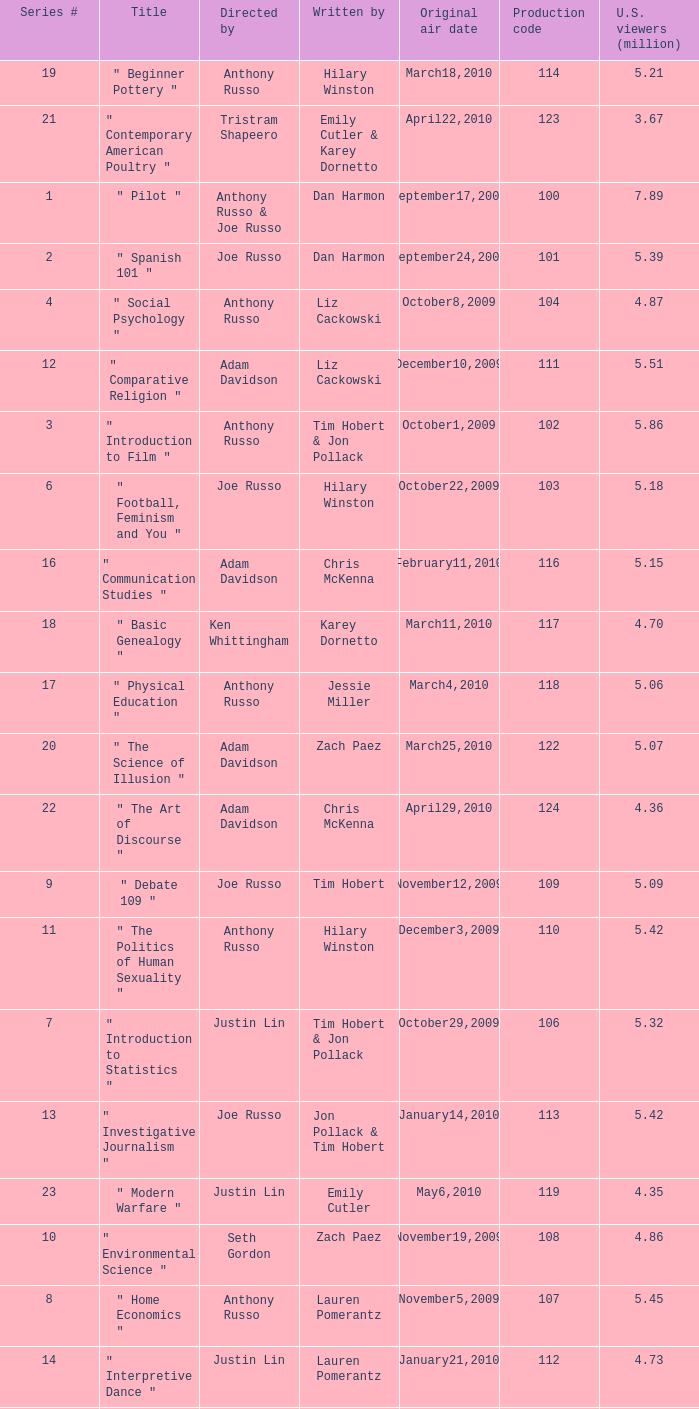Would you be able to parse every entry in this table? {'header': ['Series #', 'Title', 'Directed by', 'Written by', 'Original air date', 'Production code', 'U.S. viewers (million)'], 'rows': [['19', '" Beginner Pottery "', 'Anthony Russo', 'Hilary Winston', 'March18,2010', '114', '5.21'], ['21', '" Contemporary American Poultry "', 'Tristram Shapeero', 'Emily Cutler & Karey Dornetto', 'April22,2010', '123', '3.67'], ['1', '" Pilot "', 'Anthony Russo & Joe Russo', 'Dan Harmon', 'September17,2009', '100', '7.89'], ['2', '" Spanish 101 "', 'Joe Russo', 'Dan Harmon', 'September24,2009', '101', '5.39'], ['4', '" Social Psychology "', 'Anthony Russo', 'Liz Cackowski', 'October8,2009', '104', '4.87'], ['12', '" Comparative Religion "', 'Adam Davidson', 'Liz Cackowski', 'December10,2009', '111', '5.51'], ['3', '" Introduction to Film "', 'Anthony Russo', 'Tim Hobert & Jon Pollack', 'October1,2009', '102', '5.86'], ['6', '" Football, Feminism and You "', 'Joe Russo', 'Hilary Winston', 'October22,2009', '103', '5.18'], ['16', '" Communication Studies "', 'Adam Davidson', 'Chris McKenna', 'February11,2010', '116', '5.15'], ['18', '" Basic Genealogy "', 'Ken Whittingham', 'Karey Dornetto', 'March11,2010', '117', '4.70'], ['17', '" Physical Education "', 'Anthony Russo', 'Jessie Miller', 'March4,2010', '118', '5.06'], ['20', '" The Science of Illusion "', 'Adam Davidson', 'Zach Paez', 'March25,2010', '122', '5.07'], ['22', '" The Art of Discourse "', 'Adam Davidson', 'Chris McKenna', 'April29,2010', '124', '4.36'], ['9', '" Debate 109 "', 'Joe Russo', 'Tim Hobert', 'November12,2009', '109', '5.09'], ['11', '" The Politics of Human Sexuality "', 'Anthony Russo', 'Hilary Winston', 'December3,2009', '110', '5.42'], ['7', '" Introduction to Statistics "', 'Justin Lin', 'Tim Hobert & Jon Pollack', 'October29,2009', '106', '5.32'], ['13', '" Investigative Journalism "', 'Joe Russo', 'Jon Pollack & Tim Hobert', 'January14,2010', '113', '5.42'], ['23', '" Modern Warfare "', 'Justin Lin', 'Emily Cutler', 'May6,2010', '119', '4.35'], ['10', '" Environmental Science "', 'Seth Gordon', 'Zach Paez', 'November19,2009', '108', '4.86'], ['8', '" Home Economics "', 'Anthony Russo', 'Lauren Pomerantz', 'November5,2009', '107', '5.45'], ['14', '" Interpretive Dance "', 'Justin Lin', 'Lauren Pomerantz', 'January21,2010', '112', '4.73'], ['5', '" Advanced Criminal Law "', 'Joe Russo', 'Andrew Guest', 'October15,2009', '105', '5.01'], ['15', '" Romantic Expressionism "', 'Joe Russo', 'Andrew Guest', 'February4,2010', '115', '5.23'], ['24', '" English as a Second Language "', 'Gail Mancuso', 'Tim Hobert', 'May13,2010', '120', '4.49']]} What is the original air date when the u.s. viewers in millions was 5.39? September24,2009. 